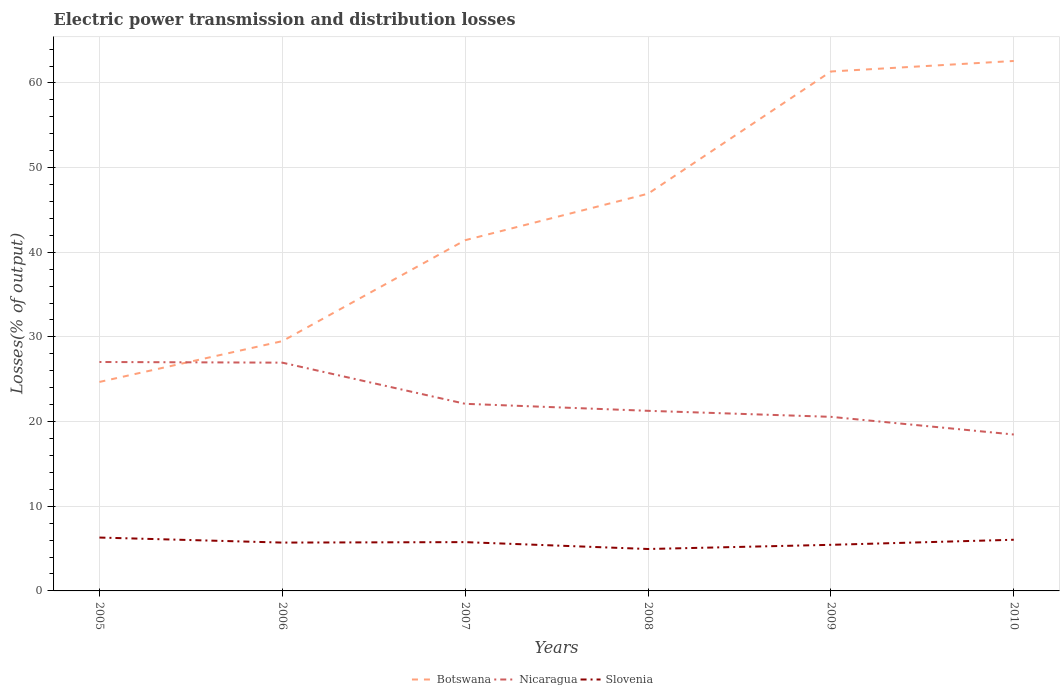Does the line corresponding to Nicaragua intersect with the line corresponding to Botswana?
Your answer should be very brief. Yes. Across all years, what is the maximum electric power transmission and distribution losses in Botswana?
Provide a succinct answer. 24.68. What is the total electric power transmission and distribution losses in Nicaragua in the graph?
Ensure brevity in your answer.  8.57. What is the difference between the highest and the second highest electric power transmission and distribution losses in Nicaragua?
Provide a succinct answer. 8.57. What is the difference between the highest and the lowest electric power transmission and distribution losses in Slovenia?
Offer a very short reply. 4. Is the electric power transmission and distribution losses in Nicaragua strictly greater than the electric power transmission and distribution losses in Slovenia over the years?
Offer a terse response. No. How many lines are there?
Offer a terse response. 3. How many years are there in the graph?
Your answer should be compact. 6. What is the difference between two consecutive major ticks on the Y-axis?
Your response must be concise. 10. Does the graph contain grids?
Your answer should be compact. Yes. How are the legend labels stacked?
Offer a very short reply. Horizontal. What is the title of the graph?
Offer a terse response. Electric power transmission and distribution losses. Does "Malaysia" appear as one of the legend labels in the graph?
Make the answer very short. No. What is the label or title of the Y-axis?
Your response must be concise. Losses(% of output). What is the Losses(% of output) of Botswana in 2005?
Ensure brevity in your answer.  24.68. What is the Losses(% of output) in Nicaragua in 2005?
Your response must be concise. 27.04. What is the Losses(% of output) of Slovenia in 2005?
Your response must be concise. 6.3. What is the Losses(% of output) of Botswana in 2006?
Keep it short and to the point. 29.5. What is the Losses(% of output) of Nicaragua in 2006?
Ensure brevity in your answer.  26.96. What is the Losses(% of output) of Slovenia in 2006?
Provide a short and direct response. 5.71. What is the Losses(% of output) of Botswana in 2007?
Make the answer very short. 41.43. What is the Losses(% of output) of Nicaragua in 2007?
Offer a very short reply. 22.1. What is the Losses(% of output) in Slovenia in 2007?
Give a very brief answer. 5.76. What is the Losses(% of output) of Botswana in 2008?
Provide a short and direct response. 46.92. What is the Losses(% of output) of Nicaragua in 2008?
Ensure brevity in your answer.  21.27. What is the Losses(% of output) of Slovenia in 2008?
Keep it short and to the point. 4.95. What is the Losses(% of output) of Botswana in 2009?
Your answer should be compact. 61.35. What is the Losses(% of output) in Nicaragua in 2009?
Your answer should be compact. 20.56. What is the Losses(% of output) in Slovenia in 2009?
Offer a very short reply. 5.44. What is the Losses(% of output) in Botswana in 2010?
Your answer should be compact. 62.59. What is the Losses(% of output) of Nicaragua in 2010?
Ensure brevity in your answer.  18.47. What is the Losses(% of output) in Slovenia in 2010?
Keep it short and to the point. 6.04. Across all years, what is the maximum Losses(% of output) of Botswana?
Keep it short and to the point. 62.59. Across all years, what is the maximum Losses(% of output) in Nicaragua?
Ensure brevity in your answer.  27.04. Across all years, what is the maximum Losses(% of output) of Slovenia?
Ensure brevity in your answer.  6.3. Across all years, what is the minimum Losses(% of output) in Botswana?
Offer a very short reply. 24.68. Across all years, what is the minimum Losses(% of output) in Nicaragua?
Offer a very short reply. 18.47. Across all years, what is the minimum Losses(% of output) of Slovenia?
Your response must be concise. 4.95. What is the total Losses(% of output) of Botswana in the graph?
Your answer should be very brief. 266.47. What is the total Losses(% of output) in Nicaragua in the graph?
Provide a succinct answer. 136.41. What is the total Losses(% of output) in Slovenia in the graph?
Your answer should be compact. 34.22. What is the difference between the Losses(% of output) in Botswana in 2005 and that in 2006?
Your answer should be very brief. -4.82. What is the difference between the Losses(% of output) of Nicaragua in 2005 and that in 2006?
Your answer should be very brief. 0.08. What is the difference between the Losses(% of output) in Slovenia in 2005 and that in 2006?
Your response must be concise. 0.59. What is the difference between the Losses(% of output) of Botswana in 2005 and that in 2007?
Give a very brief answer. -16.74. What is the difference between the Losses(% of output) in Nicaragua in 2005 and that in 2007?
Offer a very short reply. 4.94. What is the difference between the Losses(% of output) in Slovenia in 2005 and that in 2007?
Provide a short and direct response. 0.54. What is the difference between the Losses(% of output) in Botswana in 2005 and that in 2008?
Provide a short and direct response. -22.23. What is the difference between the Losses(% of output) in Nicaragua in 2005 and that in 2008?
Provide a short and direct response. 5.77. What is the difference between the Losses(% of output) in Slovenia in 2005 and that in 2008?
Provide a short and direct response. 1.35. What is the difference between the Losses(% of output) of Botswana in 2005 and that in 2009?
Your response must be concise. -36.67. What is the difference between the Losses(% of output) of Nicaragua in 2005 and that in 2009?
Make the answer very short. 6.48. What is the difference between the Losses(% of output) in Slovenia in 2005 and that in 2009?
Your answer should be compact. 0.86. What is the difference between the Losses(% of output) in Botswana in 2005 and that in 2010?
Offer a terse response. -37.91. What is the difference between the Losses(% of output) of Nicaragua in 2005 and that in 2010?
Offer a terse response. 8.57. What is the difference between the Losses(% of output) in Slovenia in 2005 and that in 2010?
Keep it short and to the point. 0.26. What is the difference between the Losses(% of output) of Botswana in 2006 and that in 2007?
Offer a very short reply. -11.92. What is the difference between the Losses(% of output) in Nicaragua in 2006 and that in 2007?
Your answer should be compact. 4.86. What is the difference between the Losses(% of output) in Slovenia in 2006 and that in 2007?
Your answer should be compact. -0.05. What is the difference between the Losses(% of output) in Botswana in 2006 and that in 2008?
Offer a very short reply. -17.41. What is the difference between the Losses(% of output) in Nicaragua in 2006 and that in 2008?
Give a very brief answer. 5.69. What is the difference between the Losses(% of output) of Slovenia in 2006 and that in 2008?
Offer a very short reply. 0.76. What is the difference between the Losses(% of output) in Botswana in 2006 and that in 2009?
Give a very brief answer. -31.85. What is the difference between the Losses(% of output) in Nicaragua in 2006 and that in 2009?
Provide a succinct answer. 6.4. What is the difference between the Losses(% of output) of Slovenia in 2006 and that in 2009?
Your answer should be very brief. 0.26. What is the difference between the Losses(% of output) of Botswana in 2006 and that in 2010?
Your answer should be very brief. -33.09. What is the difference between the Losses(% of output) of Nicaragua in 2006 and that in 2010?
Ensure brevity in your answer.  8.49. What is the difference between the Losses(% of output) in Slovenia in 2006 and that in 2010?
Your answer should be compact. -0.33. What is the difference between the Losses(% of output) in Botswana in 2007 and that in 2008?
Your answer should be very brief. -5.49. What is the difference between the Losses(% of output) of Nicaragua in 2007 and that in 2008?
Give a very brief answer. 0.83. What is the difference between the Losses(% of output) of Slovenia in 2007 and that in 2008?
Your answer should be compact. 0.81. What is the difference between the Losses(% of output) in Botswana in 2007 and that in 2009?
Your response must be concise. -19.93. What is the difference between the Losses(% of output) in Nicaragua in 2007 and that in 2009?
Ensure brevity in your answer.  1.54. What is the difference between the Losses(% of output) in Slovenia in 2007 and that in 2009?
Keep it short and to the point. 0.32. What is the difference between the Losses(% of output) in Botswana in 2007 and that in 2010?
Offer a terse response. -21.17. What is the difference between the Losses(% of output) of Nicaragua in 2007 and that in 2010?
Ensure brevity in your answer.  3.63. What is the difference between the Losses(% of output) in Slovenia in 2007 and that in 2010?
Offer a very short reply. -0.28. What is the difference between the Losses(% of output) in Botswana in 2008 and that in 2009?
Offer a terse response. -14.44. What is the difference between the Losses(% of output) of Nicaragua in 2008 and that in 2009?
Provide a succinct answer. 0.71. What is the difference between the Losses(% of output) of Slovenia in 2008 and that in 2009?
Offer a very short reply. -0.49. What is the difference between the Losses(% of output) in Botswana in 2008 and that in 2010?
Your answer should be compact. -15.68. What is the difference between the Losses(% of output) in Nicaragua in 2008 and that in 2010?
Make the answer very short. 2.8. What is the difference between the Losses(% of output) in Slovenia in 2008 and that in 2010?
Provide a short and direct response. -1.09. What is the difference between the Losses(% of output) of Botswana in 2009 and that in 2010?
Keep it short and to the point. -1.24. What is the difference between the Losses(% of output) of Nicaragua in 2009 and that in 2010?
Give a very brief answer. 2.09. What is the difference between the Losses(% of output) in Slovenia in 2009 and that in 2010?
Ensure brevity in your answer.  -0.6. What is the difference between the Losses(% of output) of Botswana in 2005 and the Losses(% of output) of Nicaragua in 2006?
Give a very brief answer. -2.28. What is the difference between the Losses(% of output) in Botswana in 2005 and the Losses(% of output) in Slovenia in 2006?
Make the answer very short. 18.97. What is the difference between the Losses(% of output) of Nicaragua in 2005 and the Losses(% of output) of Slovenia in 2006?
Ensure brevity in your answer.  21.33. What is the difference between the Losses(% of output) in Botswana in 2005 and the Losses(% of output) in Nicaragua in 2007?
Your response must be concise. 2.58. What is the difference between the Losses(% of output) of Botswana in 2005 and the Losses(% of output) of Slovenia in 2007?
Offer a terse response. 18.92. What is the difference between the Losses(% of output) of Nicaragua in 2005 and the Losses(% of output) of Slovenia in 2007?
Make the answer very short. 21.28. What is the difference between the Losses(% of output) in Botswana in 2005 and the Losses(% of output) in Nicaragua in 2008?
Offer a terse response. 3.41. What is the difference between the Losses(% of output) in Botswana in 2005 and the Losses(% of output) in Slovenia in 2008?
Give a very brief answer. 19.73. What is the difference between the Losses(% of output) of Nicaragua in 2005 and the Losses(% of output) of Slovenia in 2008?
Provide a succinct answer. 22.09. What is the difference between the Losses(% of output) of Botswana in 2005 and the Losses(% of output) of Nicaragua in 2009?
Offer a terse response. 4.12. What is the difference between the Losses(% of output) in Botswana in 2005 and the Losses(% of output) in Slovenia in 2009?
Make the answer very short. 19.24. What is the difference between the Losses(% of output) in Nicaragua in 2005 and the Losses(% of output) in Slovenia in 2009?
Provide a short and direct response. 21.6. What is the difference between the Losses(% of output) of Botswana in 2005 and the Losses(% of output) of Nicaragua in 2010?
Your answer should be compact. 6.21. What is the difference between the Losses(% of output) of Botswana in 2005 and the Losses(% of output) of Slovenia in 2010?
Provide a succinct answer. 18.64. What is the difference between the Losses(% of output) in Nicaragua in 2005 and the Losses(% of output) in Slovenia in 2010?
Give a very brief answer. 21. What is the difference between the Losses(% of output) of Botswana in 2006 and the Losses(% of output) of Nicaragua in 2007?
Make the answer very short. 7.4. What is the difference between the Losses(% of output) in Botswana in 2006 and the Losses(% of output) in Slovenia in 2007?
Your answer should be very brief. 23.74. What is the difference between the Losses(% of output) in Nicaragua in 2006 and the Losses(% of output) in Slovenia in 2007?
Make the answer very short. 21.2. What is the difference between the Losses(% of output) in Botswana in 2006 and the Losses(% of output) in Nicaragua in 2008?
Ensure brevity in your answer.  8.23. What is the difference between the Losses(% of output) of Botswana in 2006 and the Losses(% of output) of Slovenia in 2008?
Provide a short and direct response. 24.55. What is the difference between the Losses(% of output) in Nicaragua in 2006 and the Losses(% of output) in Slovenia in 2008?
Your answer should be very brief. 22.01. What is the difference between the Losses(% of output) of Botswana in 2006 and the Losses(% of output) of Nicaragua in 2009?
Offer a very short reply. 8.94. What is the difference between the Losses(% of output) in Botswana in 2006 and the Losses(% of output) in Slovenia in 2009?
Make the answer very short. 24.06. What is the difference between the Losses(% of output) in Nicaragua in 2006 and the Losses(% of output) in Slovenia in 2009?
Ensure brevity in your answer.  21.52. What is the difference between the Losses(% of output) in Botswana in 2006 and the Losses(% of output) in Nicaragua in 2010?
Make the answer very short. 11.03. What is the difference between the Losses(% of output) in Botswana in 2006 and the Losses(% of output) in Slovenia in 2010?
Keep it short and to the point. 23.46. What is the difference between the Losses(% of output) in Nicaragua in 2006 and the Losses(% of output) in Slovenia in 2010?
Your answer should be compact. 20.92. What is the difference between the Losses(% of output) in Botswana in 2007 and the Losses(% of output) in Nicaragua in 2008?
Your answer should be very brief. 20.15. What is the difference between the Losses(% of output) of Botswana in 2007 and the Losses(% of output) of Slovenia in 2008?
Offer a terse response. 36.47. What is the difference between the Losses(% of output) of Nicaragua in 2007 and the Losses(% of output) of Slovenia in 2008?
Give a very brief answer. 17.15. What is the difference between the Losses(% of output) of Botswana in 2007 and the Losses(% of output) of Nicaragua in 2009?
Give a very brief answer. 20.86. What is the difference between the Losses(% of output) of Botswana in 2007 and the Losses(% of output) of Slovenia in 2009?
Ensure brevity in your answer.  35.98. What is the difference between the Losses(% of output) of Nicaragua in 2007 and the Losses(% of output) of Slovenia in 2009?
Provide a short and direct response. 16.66. What is the difference between the Losses(% of output) of Botswana in 2007 and the Losses(% of output) of Nicaragua in 2010?
Offer a terse response. 22.95. What is the difference between the Losses(% of output) in Botswana in 2007 and the Losses(% of output) in Slovenia in 2010?
Your answer should be very brief. 35.38. What is the difference between the Losses(% of output) of Nicaragua in 2007 and the Losses(% of output) of Slovenia in 2010?
Offer a terse response. 16.06. What is the difference between the Losses(% of output) of Botswana in 2008 and the Losses(% of output) of Nicaragua in 2009?
Your answer should be compact. 26.35. What is the difference between the Losses(% of output) in Botswana in 2008 and the Losses(% of output) in Slovenia in 2009?
Your response must be concise. 41.47. What is the difference between the Losses(% of output) in Nicaragua in 2008 and the Losses(% of output) in Slovenia in 2009?
Provide a short and direct response. 15.83. What is the difference between the Losses(% of output) of Botswana in 2008 and the Losses(% of output) of Nicaragua in 2010?
Provide a short and direct response. 28.44. What is the difference between the Losses(% of output) in Botswana in 2008 and the Losses(% of output) in Slovenia in 2010?
Offer a very short reply. 40.87. What is the difference between the Losses(% of output) of Nicaragua in 2008 and the Losses(% of output) of Slovenia in 2010?
Keep it short and to the point. 15.23. What is the difference between the Losses(% of output) of Botswana in 2009 and the Losses(% of output) of Nicaragua in 2010?
Offer a very short reply. 42.88. What is the difference between the Losses(% of output) in Botswana in 2009 and the Losses(% of output) in Slovenia in 2010?
Make the answer very short. 55.31. What is the difference between the Losses(% of output) of Nicaragua in 2009 and the Losses(% of output) of Slovenia in 2010?
Ensure brevity in your answer.  14.52. What is the average Losses(% of output) in Botswana per year?
Your answer should be compact. 44.41. What is the average Losses(% of output) in Nicaragua per year?
Provide a short and direct response. 22.74. What is the average Losses(% of output) of Slovenia per year?
Give a very brief answer. 5.7. In the year 2005, what is the difference between the Losses(% of output) of Botswana and Losses(% of output) of Nicaragua?
Your answer should be very brief. -2.36. In the year 2005, what is the difference between the Losses(% of output) in Botswana and Losses(% of output) in Slovenia?
Your answer should be compact. 18.38. In the year 2005, what is the difference between the Losses(% of output) in Nicaragua and Losses(% of output) in Slovenia?
Give a very brief answer. 20.74. In the year 2006, what is the difference between the Losses(% of output) in Botswana and Losses(% of output) in Nicaragua?
Offer a very short reply. 2.54. In the year 2006, what is the difference between the Losses(% of output) in Botswana and Losses(% of output) in Slovenia?
Your response must be concise. 23.79. In the year 2006, what is the difference between the Losses(% of output) of Nicaragua and Losses(% of output) of Slovenia?
Your answer should be compact. 21.25. In the year 2007, what is the difference between the Losses(% of output) in Botswana and Losses(% of output) in Nicaragua?
Give a very brief answer. 19.32. In the year 2007, what is the difference between the Losses(% of output) in Botswana and Losses(% of output) in Slovenia?
Your answer should be compact. 35.66. In the year 2007, what is the difference between the Losses(% of output) in Nicaragua and Losses(% of output) in Slovenia?
Your response must be concise. 16.34. In the year 2008, what is the difference between the Losses(% of output) of Botswana and Losses(% of output) of Nicaragua?
Offer a very short reply. 25.64. In the year 2008, what is the difference between the Losses(% of output) in Botswana and Losses(% of output) in Slovenia?
Provide a succinct answer. 41.96. In the year 2008, what is the difference between the Losses(% of output) of Nicaragua and Losses(% of output) of Slovenia?
Offer a terse response. 16.32. In the year 2009, what is the difference between the Losses(% of output) in Botswana and Losses(% of output) in Nicaragua?
Provide a short and direct response. 40.79. In the year 2009, what is the difference between the Losses(% of output) of Botswana and Losses(% of output) of Slovenia?
Offer a very short reply. 55.91. In the year 2009, what is the difference between the Losses(% of output) of Nicaragua and Losses(% of output) of Slovenia?
Offer a terse response. 15.12. In the year 2010, what is the difference between the Losses(% of output) of Botswana and Losses(% of output) of Nicaragua?
Provide a succinct answer. 44.12. In the year 2010, what is the difference between the Losses(% of output) of Botswana and Losses(% of output) of Slovenia?
Offer a very short reply. 56.55. In the year 2010, what is the difference between the Losses(% of output) of Nicaragua and Losses(% of output) of Slovenia?
Ensure brevity in your answer.  12.43. What is the ratio of the Losses(% of output) of Botswana in 2005 to that in 2006?
Ensure brevity in your answer.  0.84. What is the ratio of the Losses(% of output) in Slovenia in 2005 to that in 2006?
Your response must be concise. 1.1. What is the ratio of the Losses(% of output) in Botswana in 2005 to that in 2007?
Give a very brief answer. 0.6. What is the ratio of the Losses(% of output) of Nicaragua in 2005 to that in 2007?
Your answer should be compact. 1.22. What is the ratio of the Losses(% of output) in Slovenia in 2005 to that in 2007?
Provide a succinct answer. 1.09. What is the ratio of the Losses(% of output) in Botswana in 2005 to that in 2008?
Provide a short and direct response. 0.53. What is the ratio of the Losses(% of output) of Nicaragua in 2005 to that in 2008?
Offer a terse response. 1.27. What is the ratio of the Losses(% of output) in Slovenia in 2005 to that in 2008?
Your response must be concise. 1.27. What is the ratio of the Losses(% of output) in Botswana in 2005 to that in 2009?
Make the answer very short. 0.4. What is the ratio of the Losses(% of output) of Nicaragua in 2005 to that in 2009?
Make the answer very short. 1.32. What is the ratio of the Losses(% of output) of Slovenia in 2005 to that in 2009?
Give a very brief answer. 1.16. What is the ratio of the Losses(% of output) in Botswana in 2005 to that in 2010?
Give a very brief answer. 0.39. What is the ratio of the Losses(% of output) in Nicaragua in 2005 to that in 2010?
Your answer should be compact. 1.46. What is the ratio of the Losses(% of output) of Slovenia in 2005 to that in 2010?
Give a very brief answer. 1.04. What is the ratio of the Losses(% of output) of Botswana in 2006 to that in 2007?
Provide a succinct answer. 0.71. What is the ratio of the Losses(% of output) in Nicaragua in 2006 to that in 2007?
Your answer should be compact. 1.22. What is the ratio of the Losses(% of output) in Slovenia in 2006 to that in 2007?
Provide a short and direct response. 0.99. What is the ratio of the Losses(% of output) of Botswana in 2006 to that in 2008?
Give a very brief answer. 0.63. What is the ratio of the Losses(% of output) of Nicaragua in 2006 to that in 2008?
Your answer should be very brief. 1.27. What is the ratio of the Losses(% of output) of Slovenia in 2006 to that in 2008?
Ensure brevity in your answer.  1.15. What is the ratio of the Losses(% of output) in Botswana in 2006 to that in 2009?
Offer a very short reply. 0.48. What is the ratio of the Losses(% of output) in Nicaragua in 2006 to that in 2009?
Offer a very short reply. 1.31. What is the ratio of the Losses(% of output) of Slovenia in 2006 to that in 2009?
Keep it short and to the point. 1.05. What is the ratio of the Losses(% of output) in Botswana in 2006 to that in 2010?
Provide a succinct answer. 0.47. What is the ratio of the Losses(% of output) of Nicaragua in 2006 to that in 2010?
Give a very brief answer. 1.46. What is the ratio of the Losses(% of output) of Slovenia in 2006 to that in 2010?
Your answer should be compact. 0.94. What is the ratio of the Losses(% of output) of Botswana in 2007 to that in 2008?
Offer a very short reply. 0.88. What is the ratio of the Losses(% of output) in Nicaragua in 2007 to that in 2008?
Your response must be concise. 1.04. What is the ratio of the Losses(% of output) in Slovenia in 2007 to that in 2008?
Your answer should be compact. 1.16. What is the ratio of the Losses(% of output) of Botswana in 2007 to that in 2009?
Ensure brevity in your answer.  0.68. What is the ratio of the Losses(% of output) of Nicaragua in 2007 to that in 2009?
Offer a very short reply. 1.07. What is the ratio of the Losses(% of output) of Slovenia in 2007 to that in 2009?
Offer a terse response. 1.06. What is the ratio of the Losses(% of output) in Botswana in 2007 to that in 2010?
Your response must be concise. 0.66. What is the ratio of the Losses(% of output) in Nicaragua in 2007 to that in 2010?
Your answer should be very brief. 1.2. What is the ratio of the Losses(% of output) in Slovenia in 2007 to that in 2010?
Your response must be concise. 0.95. What is the ratio of the Losses(% of output) in Botswana in 2008 to that in 2009?
Offer a terse response. 0.76. What is the ratio of the Losses(% of output) of Nicaragua in 2008 to that in 2009?
Give a very brief answer. 1.03. What is the ratio of the Losses(% of output) of Slovenia in 2008 to that in 2009?
Provide a succinct answer. 0.91. What is the ratio of the Losses(% of output) of Botswana in 2008 to that in 2010?
Your response must be concise. 0.75. What is the ratio of the Losses(% of output) in Nicaragua in 2008 to that in 2010?
Offer a terse response. 1.15. What is the ratio of the Losses(% of output) of Slovenia in 2008 to that in 2010?
Provide a succinct answer. 0.82. What is the ratio of the Losses(% of output) in Botswana in 2009 to that in 2010?
Give a very brief answer. 0.98. What is the ratio of the Losses(% of output) of Nicaragua in 2009 to that in 2010?
Your answer should be compact. 1.11. What is the ratio of the Losses(% of output) in Slovenia in 2009 to that in 2010?
Your answer should be compact. 0.9. What is the difference between the highest and the second highest Losses(% of output) of Botswana?
Ensure brevity in your answer.  1.24. What is the difference between the highest and the second highest Losses(% of output) of Nicaragua?
Make the answer very short. 0.08. What is the difference between the highest and the second highest Losses(% of output) in Slovenia?
Your answer should be compact. 0.26. What is the difference between the highest and the lowest Losses(% of output) of Botswana?
Your answer should be compact. 37.91. What is the difference between the highest and the lowest Losses(% of output) in Nicaragua?
Provide a short and direct response. 8.57. What is the difference between the highest and the lowest Losses(% of output) of Slovenia?
Your response must be concise. 1.35. 